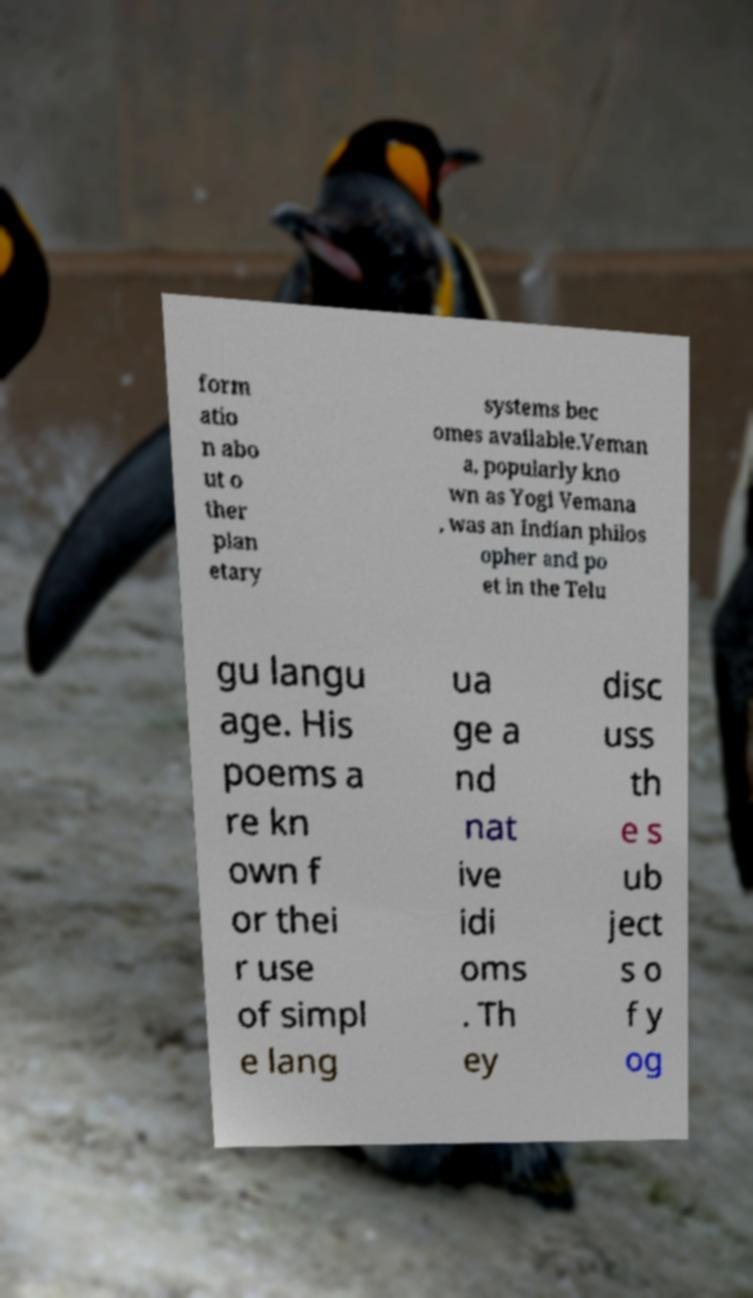Could you assist in decoding the text presented in this image and type it out clearly? form atio n abo ut o ther plan etary systems bec omes available.Veman a, popularly kno wn as Yogi Vemana , was an Indian philos opher and po et in the Telu gu langu age. His poems a re kn own f or thei r use of simpl e lang ua ge a nd nat ive idi oms . Th ey disc uss th e s ub ject s o f y og 